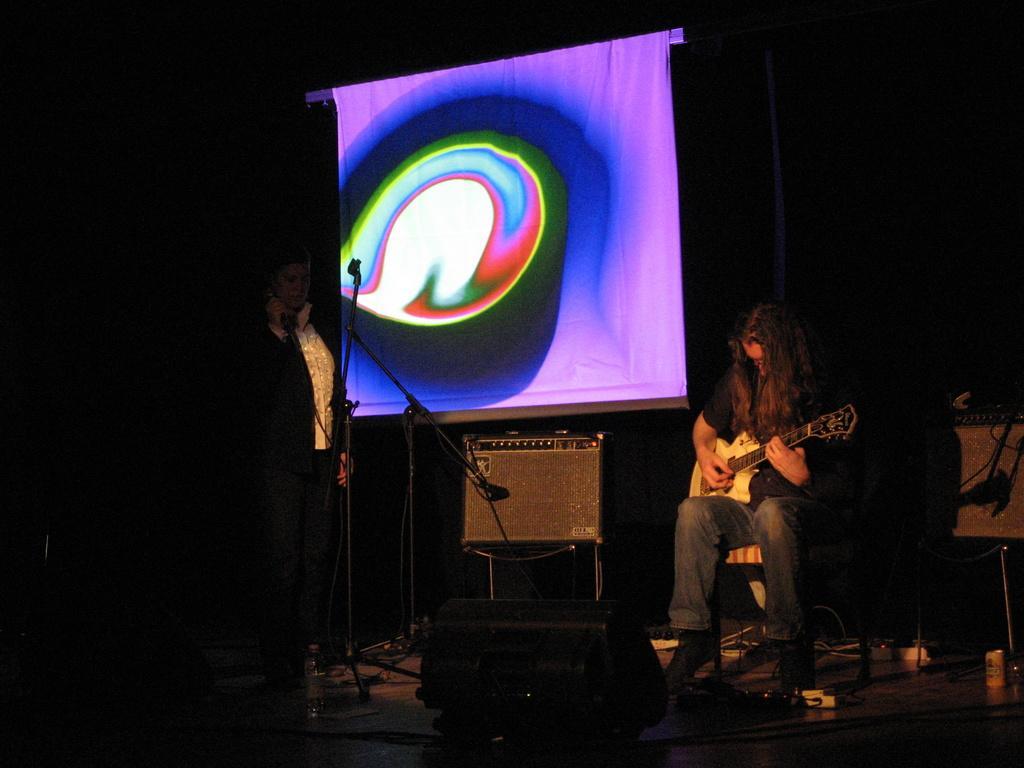Describe this image in one or two sentences. In this image there are two persons, there is person sitting and playing a musical instrument, there is a person holding an object, there are stands, there is a microphone, there are wires, there are objects on the stage, there is an object on the chair, there is an object truncated towards the right of the image, there is a screen, the background of the image is dark. 